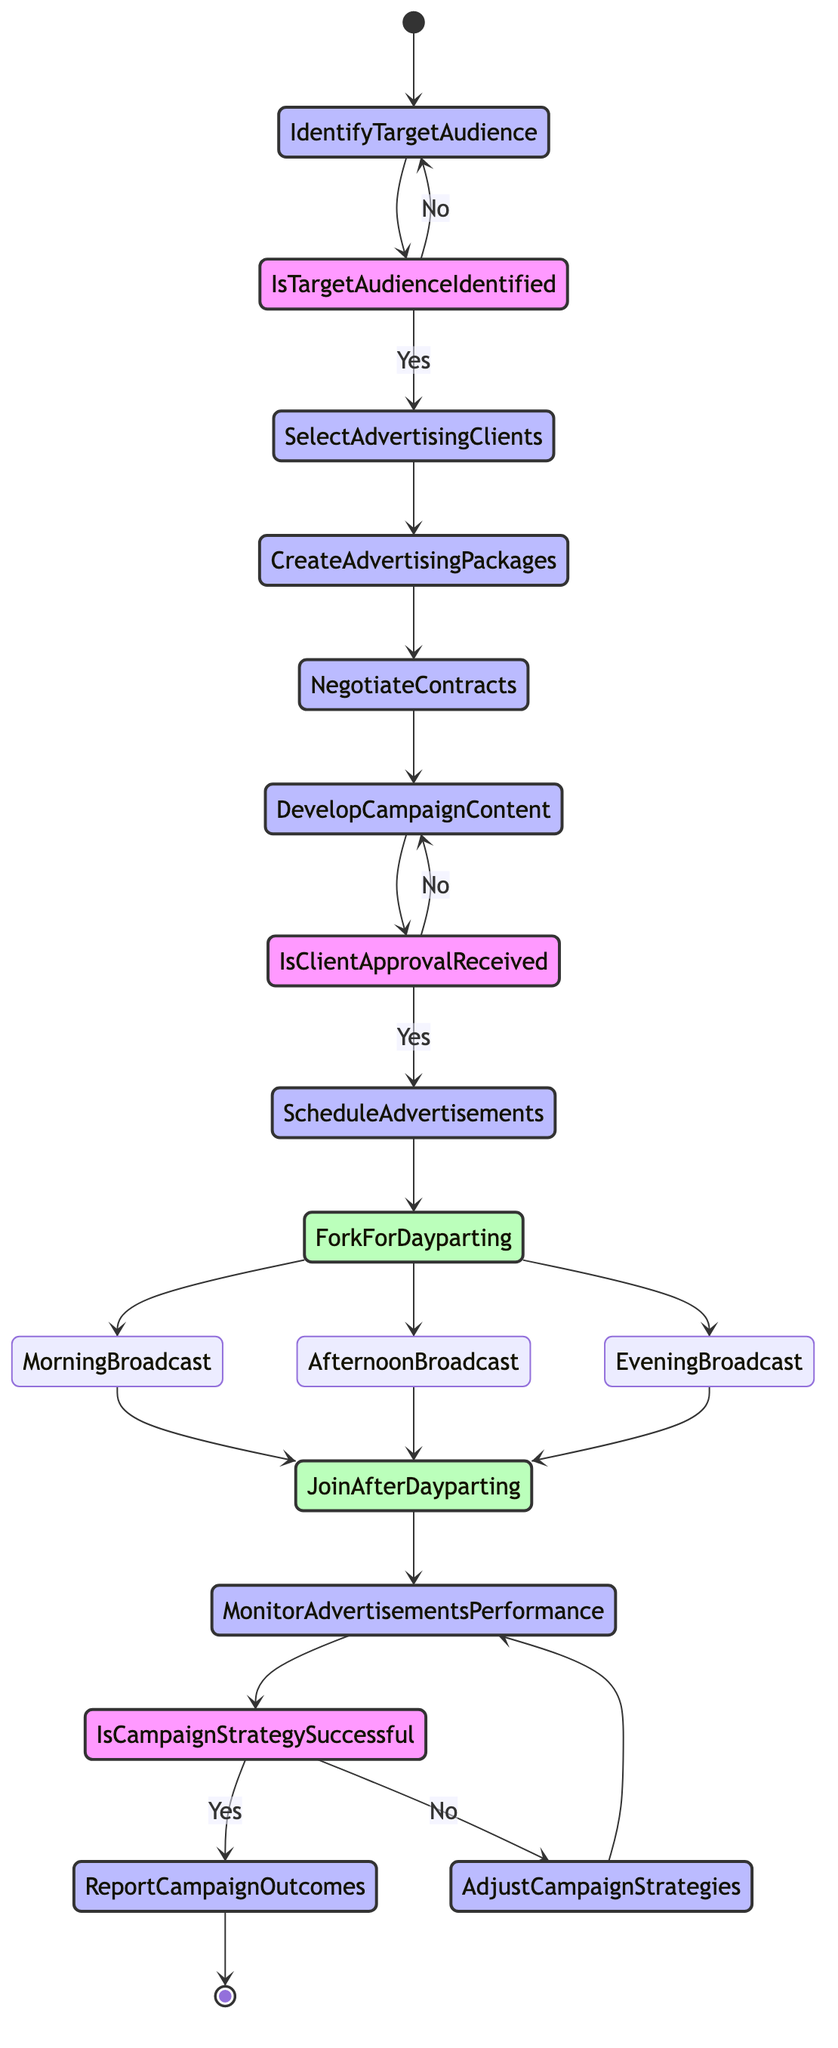What is the starting point of the activity diagram? The starting point of the activity diagram is labeled as "Start Campaign Management." This indicates the initial activity where the advertising campaign management process begins.
Answer: Start Campaign Management How many decisions are present in the diagram? There are three decision points indicated by the nodes labeled "Is Target Audience Identified?", "Is Client Approval Received for Content?", and "Is Campaign Strategy Successful?" This results in a total of three decision nodes.
Answer: 3 What comes after scheduling advertisements? After scheduling advertisements, the flow moves to a fork labeled "Fork for Dayparting." This means that the process will split into different branches based on the time of day when advertisements will be broadcast.
Answer: Fork for Dayparting What activity occurs when the campaign strategy is unsuccessful? If the campaign strategy is unsuccessful, the flow leads to "Adjust Campaign Strategies." This indicates that there will be a need to modify the advertising strategy based on performance evaluation.
Answer: Adjust Campaign Strategies Which activity must receive client approval before proceeding? The activity that requires client approval before proceeding is "Develop Campaign Content." If this content is not approved, the flow loops back to the same activity for further adjustments.
Answer: Develop Campaign Content What do the activities "Morning Broadcast," "Afternoon Broadcast," and "Evening Broadcast" represent? These activities represent segments of time when advertisements are scheduled to be aired, aligning the ads with different listener demographics based on the time of day. This indicates a tailored approach to broadcasting advertisements.
Answer: Broadcasting times What is the endpoint of the activity diagram? The endpoint of the activity diagram is labeled as "End Campaign Management." This signifies the conclusion of all activities related to the advertising campaign management process, including delivering the final report.
Answer: End Campaign Management What happens to the advertisements after they are broadcast? After the advertisements are broadcast, the next activity is to "Monitor Advertisements Performance." This involves tracking the effectiveness of the aired ads using metrics such as listener feedback and engagement.
Answer: Monitor Advertisements Performance What is required before selecting advertising clients? Before selecting advertising clients, it is required to "Identify Target Audience." This step involves analyzing listener demographics and preferences to ensure alignment with the potential advertisers' products or services.
Answer: Identify Target Audience 